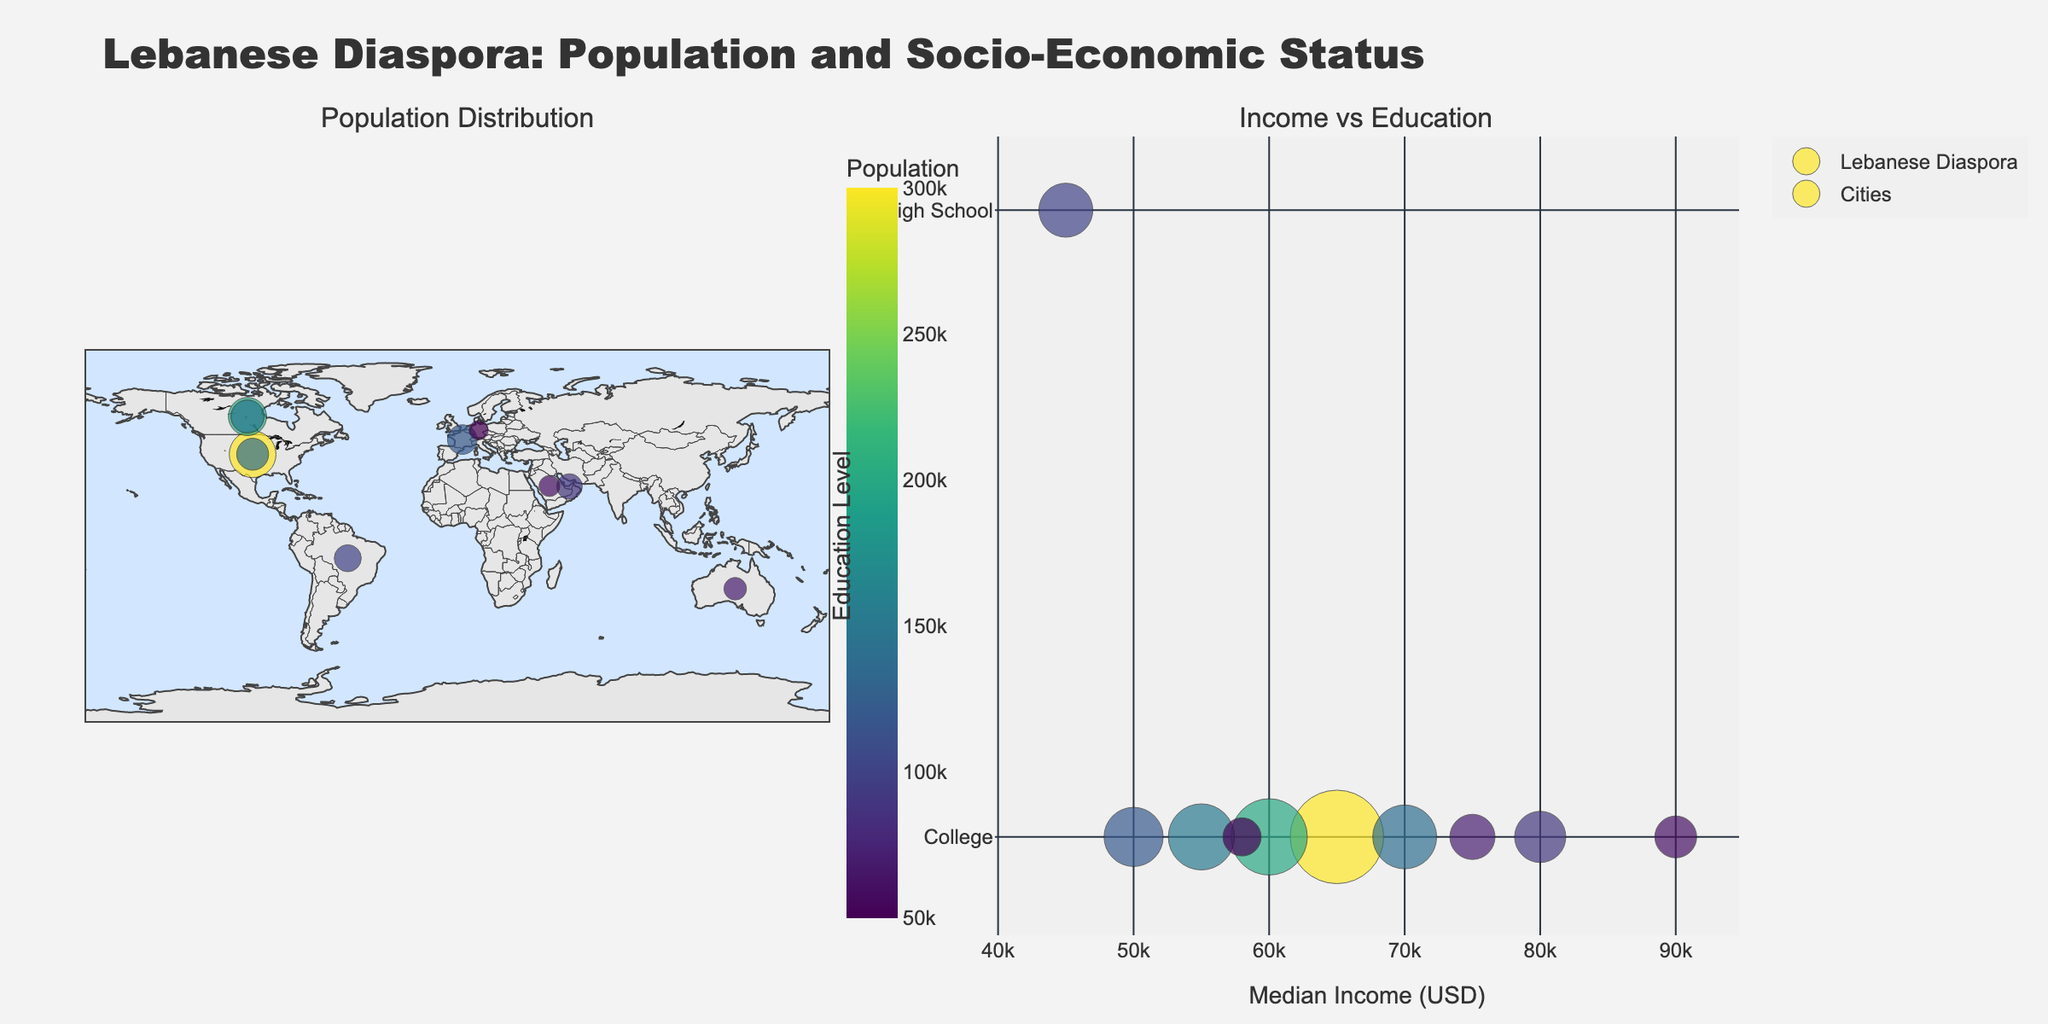What's the title of the figure? The title of the figure is located at the top center and usually summarizes the content of the figure. It states: "Lebanese Diaspora: Population and Socio-Economic Status".
Answer: Lebanese Diaspora: Population and Socio-Economic Status How many cities are represented in the bubble chart? To determine the number of cities, you count the different bubbles across both subplots. Each bubble represents a different city.
Answer: 10 What does the color of the bubbles represent in the charts? The color of the bubbles corresponds to the population size, with a colorscale from lighter to darker shades. The colorscale bar labeled "Population" clarifies this.
Answer: Population Which country has the city with the highest Median Income? To find this, look at the second subplot (Income vs Education). The x-axis represents median income, and the city with the highest x-position represents the highest median income. According to the data points, Riyadh in Saudi Arabia has the highest median income.
Answer: Saudi Arabia Which city has the smallest Lebanese diaspora population? Look at both the plotted bubbles in the figure. The smallest circle represents the smallest population size. The data point with the smallest circle size corresponds to Berlin.
Answer: Berlin How many cities have a Median Income above 70,000 USD? Examine the bubbles on the second subplot (Income vs Education). Count the number of bubbles positioned beyond 70,000 on the x-axis. There are three cities: Los Angeles, Dubai, and Riyadh.
Answer: 3 Which country has the most Lebanese diaspora in total across all its cities in the plot? Here, you need to sum the populations of cities within each country. The totals are: United States (300,000 + 140,000), Canada (200,000 + 150,000), France (120,000), Brazil (100,000), UAE (90,000), Saudi Arabia (60,000), Australia (70,000), Germany (50,000). The United States has the highest total: 440,000.
Answer: United States How does the median income in Sydney compare to that in Montreal? Compare the x-positions of Sydney and Montreal in the second subplot. Sydney's median income is higher than Montreal's based on its more rightward position.
Answer: Sydney's median income is higher Which city has the highest education level but a lower population size? Identify the city with the highest education level (College) and then pick the one with the smaller population by comparing the size of the circles. Berlin has a lower population but equals others in education level (College).
Answer: Berlin 